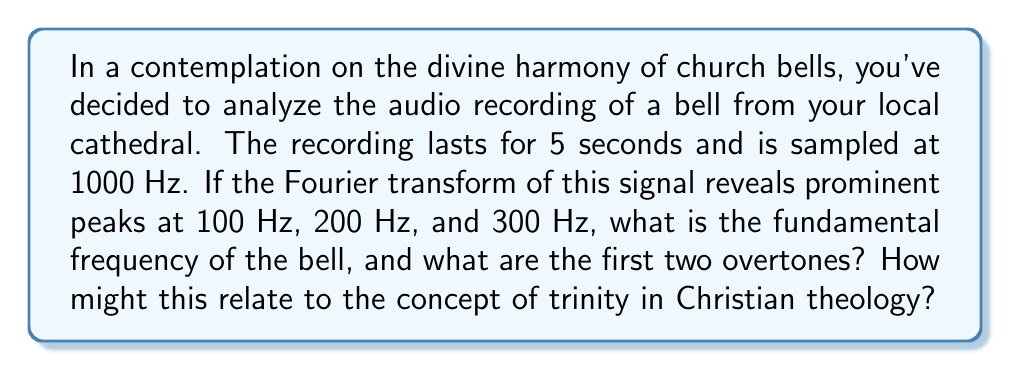Provide a solution to this math problem. To solve this problem, we need to understand the relationship between fundamental frequency and overtones in the context of the Fourier transform:

1) The Fourier transform decomposes a signal into its constituent frequencies. In the case of a church bell, these frequencies correspond to the fundamental tone and its overtones.

2) The fundamental frequency is the lowest frequency component with significant amplitude. It corresponds to the perceived pitch of the bell.

3) Overtones are integer multiples of the fundamental frequency. They contribute to the timbre or "color" of the sound.

4) Given the prominent peaks at 100 Hz, 200 Hz, and 300 Hz, we can deduce:

   $$f_1 = 100 \text{ Hz}$$
   $$f_2 = 200 \text{ Hz} = 2f_1$$
   $$f_3 = 300 \text{ Hz} = 3f_1$$

5) Since these frequencies form an arithmetic sequence with a common difference equal to the first term, we can conclude that 100 Hz is the fundamental frequency.

6) The first overtone is the second harmonic (200 Hz), and the second overtone is the third harmonic (300 Hz).

Theological reflection: The presence of three distinct, harmonious frequencies might be seen as a reflection of the Christian concept of the Trinity - three distinct persons in one divine nature, each integral to the whole, just as these frequencies combine to create the rich, resonant sound of the church bell.
Answer: Fundamental frequency: 100 Hz
First overtone: 200 Hz
Second overtone: 300 Hz 